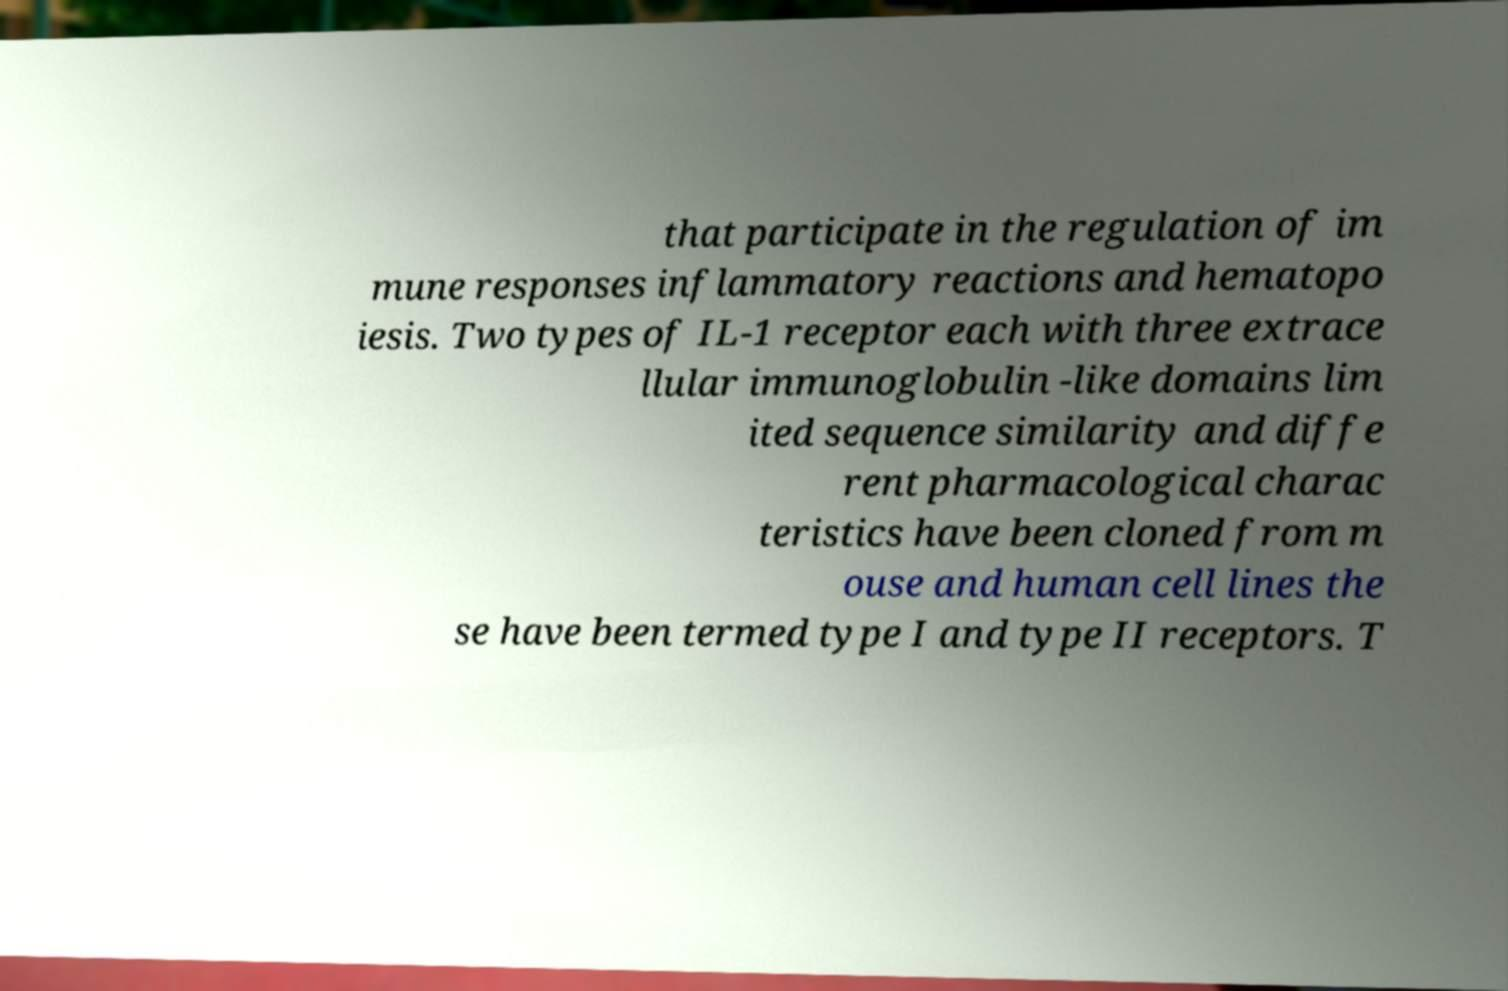What messages or text are displayed in this image? I need them in a readable, typed format. that participate in the regulation of im mune responses inflammatory reactions and hematopo iesis. Two types of IL-1 receptor each with three extrace llular immunoglobulin -like domains lim ited sequence similarity and diffe rent pharmacological charac teristics have been cloned from m ouse and human cell lines the se have been termed type I and type II receptors. T 